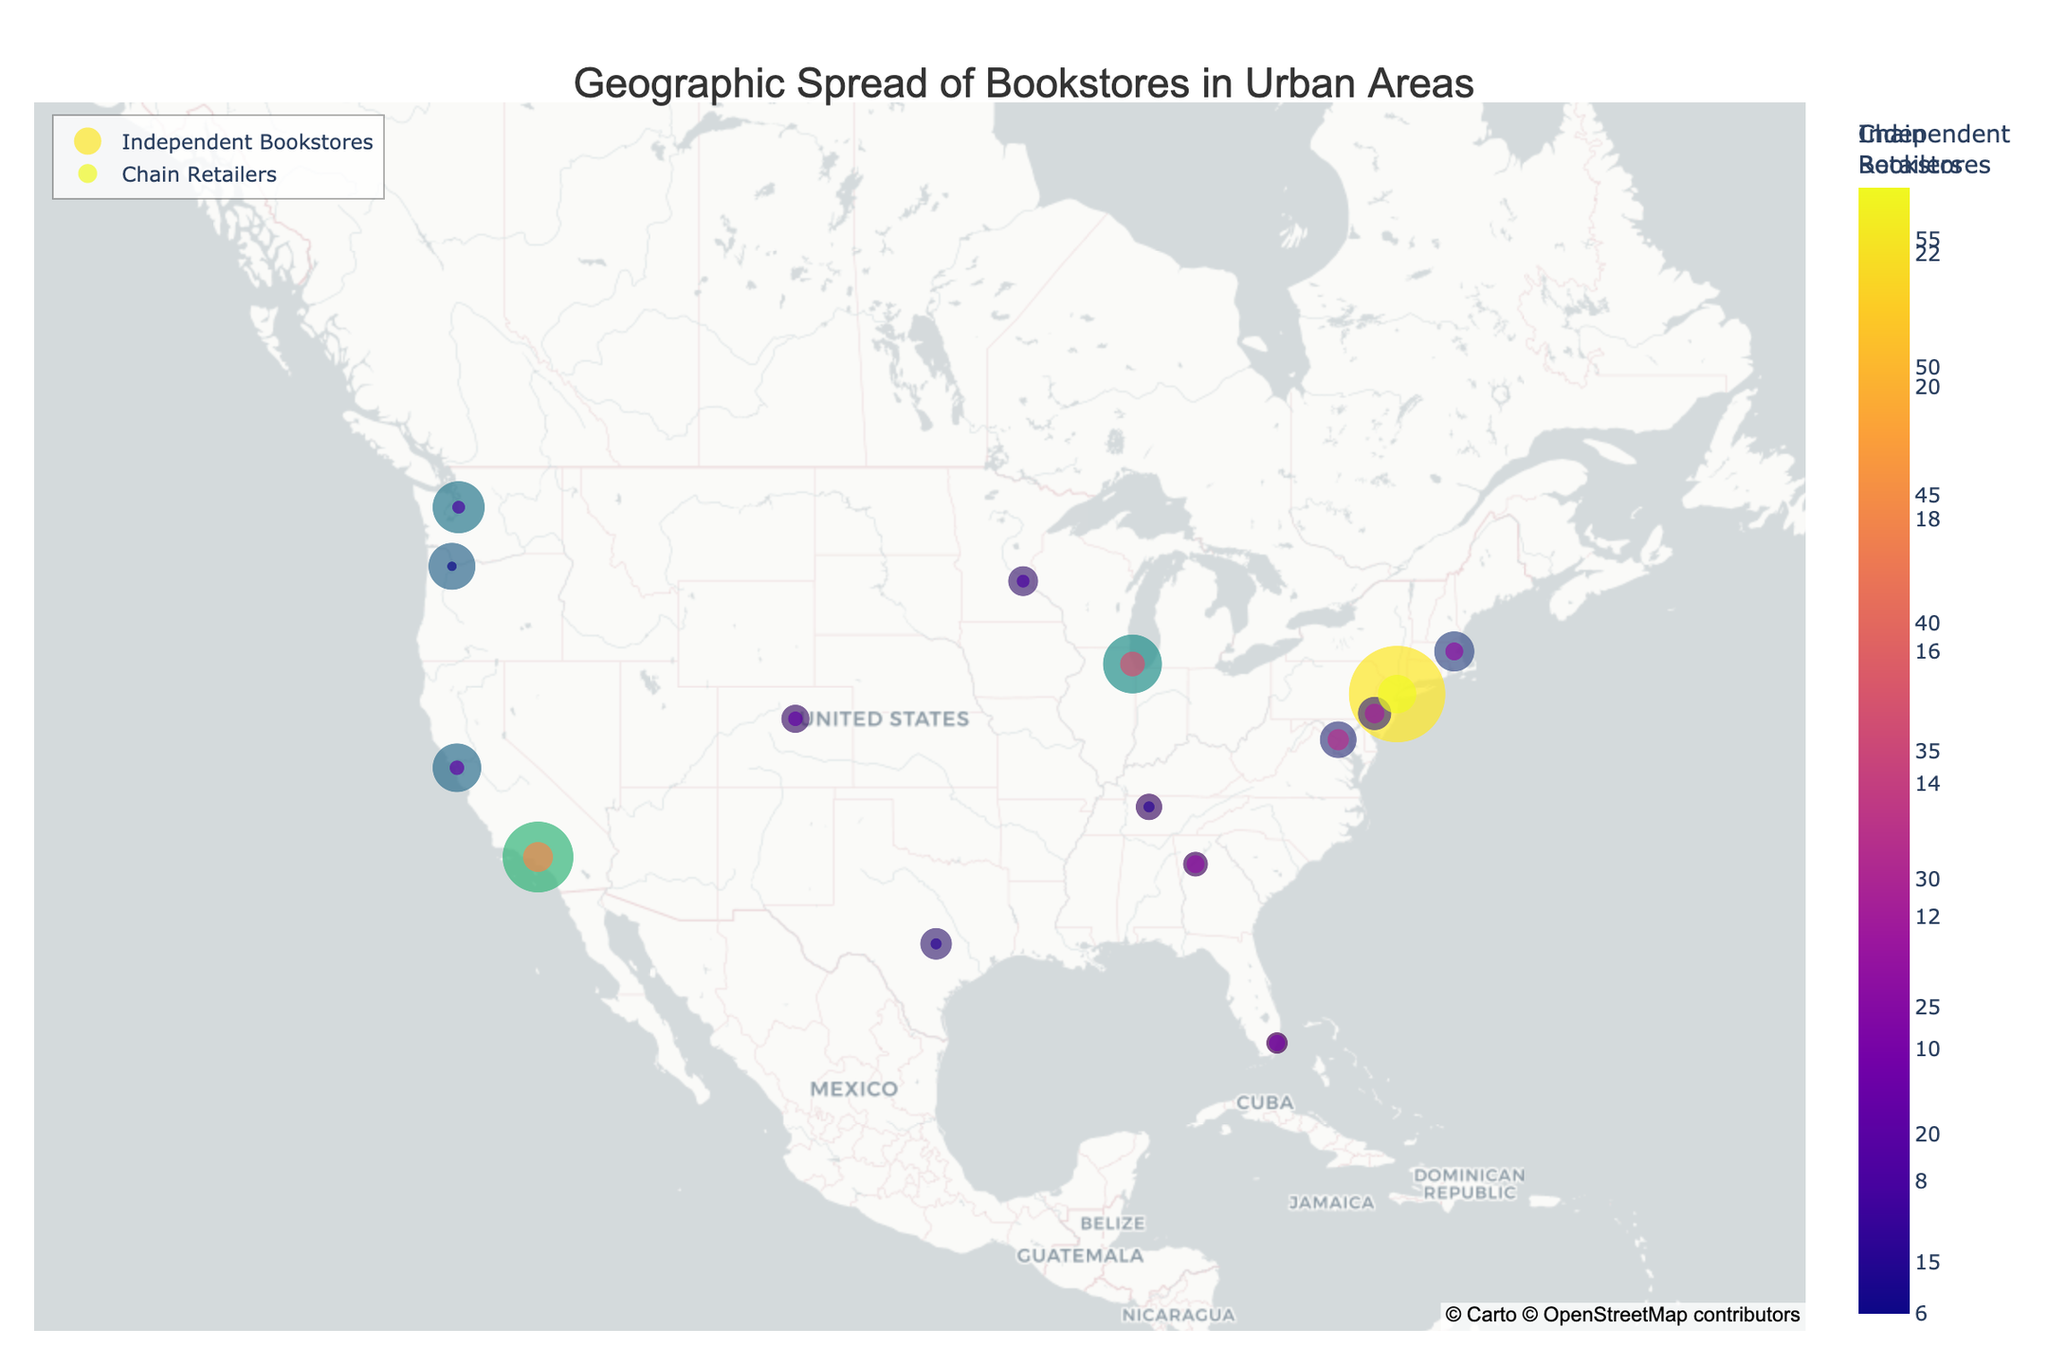Which city has the highest number of independent bookstores? By observing the marker size and checking the hover info on the map, New York City has the highest number of independent bookstores.
Answer: New York Which city has more chain retailers than independent bookstores? By comparing the visual sizes and colors of the markers for each city, all cities have more independent bookstores compared to chain retailers.
Answer: None How many independent bookstores are there in Los Angeles? Check the hover info on the map for Los Angeles; it shows 42 independent bookstores.
Answer: 42 What is the difference in the number of independent bookstores between Seattle and Portland? Seattle has 31 independent bookstores while Portland has 28. The difference is 31 - 28.
Answer: 3 Which city has the fewest chain retailers? Looking at the markers and hover info for chain retailers, Portland has the fewest with 6 chain retailers.
Answer: Portland What is the average number of independent bookstores across all cities? Sum the number of independent bookstores for all cities and divide by the total number of cities. Sum is (57 + 42 + 35 + 29 + 24 + 31 + 28 + 22 + 19 + 17 + 20 + 18 + 15 + 13 + 16) = 366. There are 15 cities, so the average is 366 / 15.
Answer: 24.4 Which city has the greatest disparity between the number of independent bookstores and chain retailers? Identify the disparities for each city by subtraction; New York has 57 - 23 = 34, which is the highest disparity.
Answer: New York In which geographic region of the United States do we see a higher density of independent bookstores? Observing the map, the Northeast (including New York, Boston, and Philadelphia) and the West Coast (including Los Angeles, San Francisco, Seattle, and Portland) show a higher density.
Answer: Northeast and West Coast How are the cities clustered based on their number of chain retailers? By observing the color coding and marker sizes, we see that most cities have between 6 and 13 chain retailers with no extreme outliers.
Answer: Between 6 and 13 chain retailers 